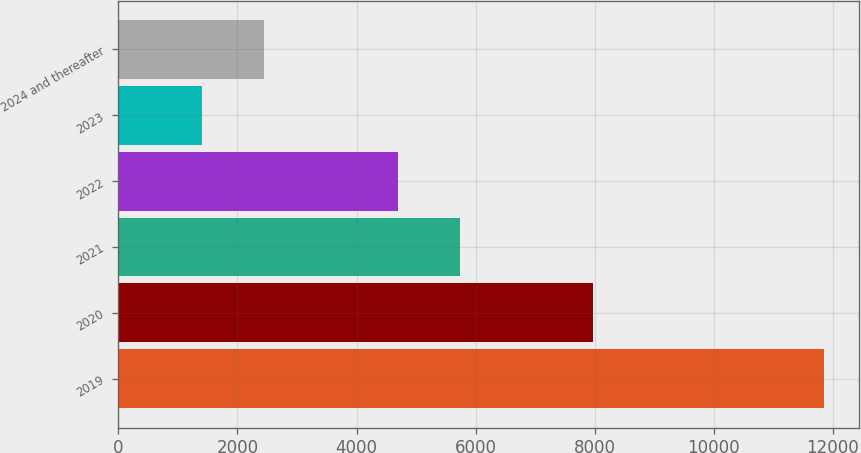Convert chart to OTSL. <chart><loc_0><loc_0><loc_500><loc_500><bar_chart><fcel>2019<fcel>2020<fcel>2021<fcel>2022<fcel>2023<fcel>2024 and thereafter<nl><fcel>11847<fcel>7965<fcel>5741.3<fcel>4697<fcel>1404<fcel>2448.3<nl></chart> 